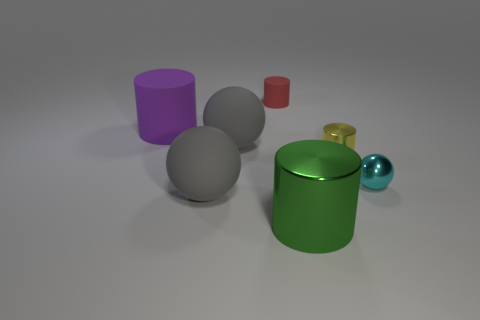Are there fewer green objects to the right of the large green cylinder than gray matte things behind the large purple cylinder?
Provide a short and direct response. No. How many shiny objects are both in front of the yellow object and on the left side of the tiny ball?
Offer a very short reply. 1. The big gray ball left of the ball behind the yellow shiny object is made of what material?
Ensure brevity in your answer.  Rubber. Is there a thing made of the same material as the small cyan sphere?
Offer a very short reply. Yes. What is the material of the yellow object that is the same size as the metal sphere?
Your answer should be compact. Metal. What is the size of the matte cylinder that is in front of the rubber cylinder right of the gray ball that is behind the cyan thing?
Make the answer very short. Large. Is there a sphere that is in front of the gray matte object in front of the cyan metallic ball?
Make the answer very short. No. Do the big green thing and the gray rubber thing that is behind the tiny cyan sphere have the same shape?
Your answer should be compact. No. There is a tiny cylinder in front of the tiny red rubber cylinder; what color is it?
Your answer should be very brief. Yellow. There is a matte object that is on the right side of the big gray matte thing that is behind the small metallic ball; what size is it?
Your answer should be compact. Small. 